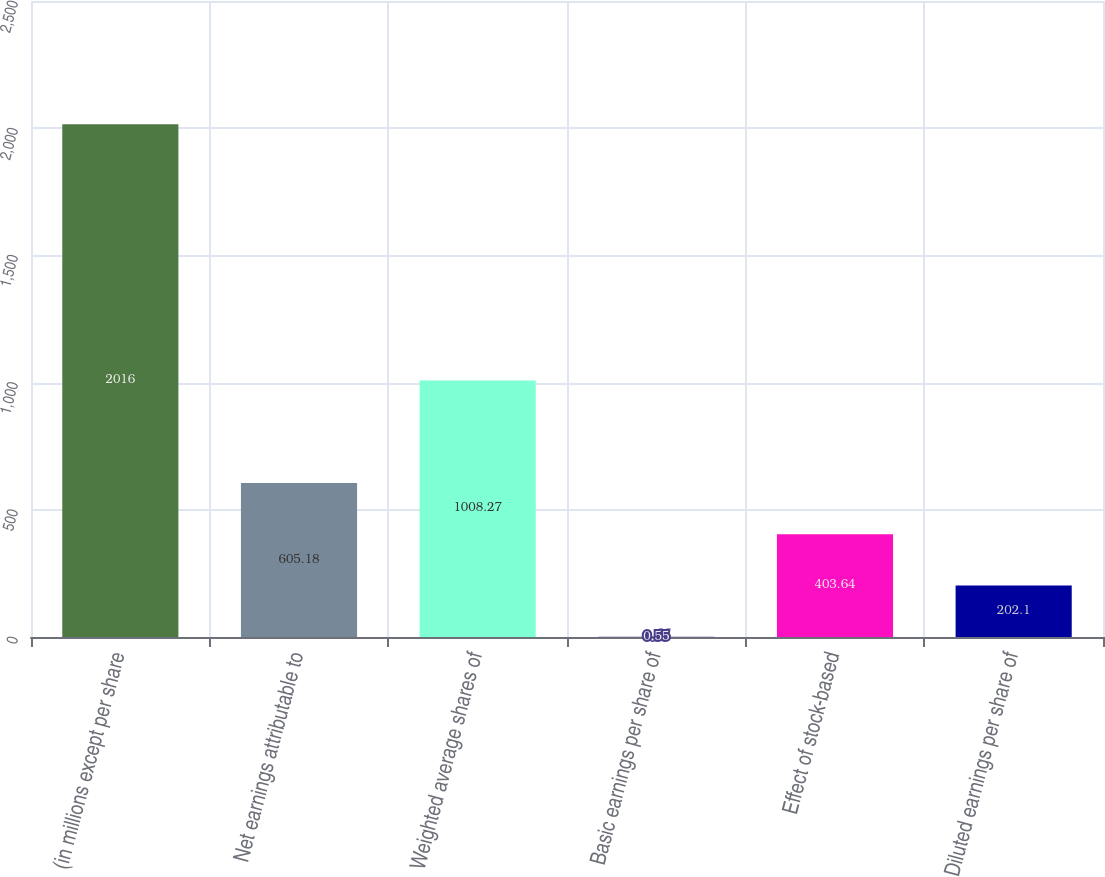Convert chart. <chart><loc_0><loc_0><loc_500><loc_500><bar_chart><fcel>(in millions except per share<fcel>Net earnings attributable to<fcel>Weighted average shares of<fcel>Basic earnings per share of<fcel>Effect of stock-based<fcel>Diluted earnings per share of<nl><fcel>2016<fcel>605.18<fcel>1008.27<fcel>0.55<fcel>403.64<fcel>202.1<nl></chart> 